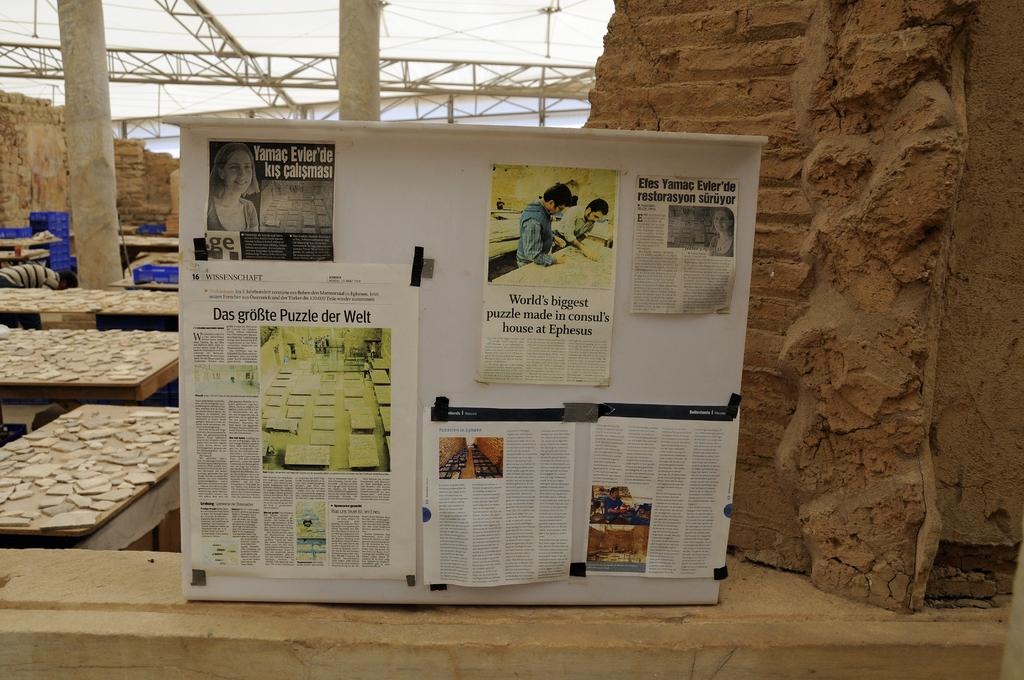<image>
Describe the image concisely. A board with newspapers tacked on it, one that talks about the 'word's biggest puzzle' 